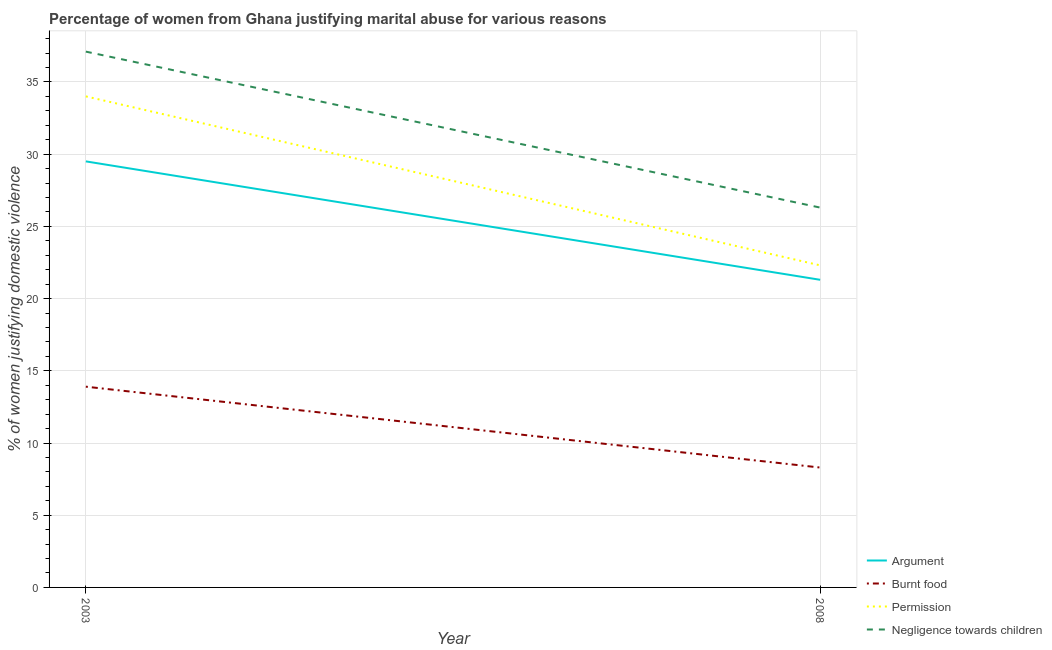What is the percentage of women justifying abuse in the case of an argument in 2003?
Give a very brief answer. 29.5. Across all years, what is the minimum percentage of women justifying abuse in the case of an argument?
Offer a terse response. 21.3. What is the total percentage of women justifying abuse for burning food in the graph?
Your answer should be very brief. 22.2. What is the difference between the percentage of women justifying abuse for burning food in 2003 and that in 2008?
Your answer should be very brief. 5.6. What is the difference between the percentage of women justifying abuse in the case of an argument in 2003 and the percentage of women justifying abuse for burning food in 2008?
Offer a very short reply. 21.2. What is the average percentage of women justifying abuse in the case of an argument per year?
Provide a short and direct response. 25.4. In the year 2003, what is the difference between the percentage of women justifying abuse for going without permission and percentage of women justifying abuse in the case of an argument?
Ensure brevity in your answer.  4.5. What is the ratio of the percentage of women justifying abuse for going without permission in 2003 to that in 2008?
Offer a terse response. 1.52. Is the percentage of women justifying abuse for showing negligence towards children strictly greater than the percentage of women justifying abuse for going without permission over the years?
Offer a very short reply. Yes. How many years are there in the graph?
Offer a terse response. 2. What is the difference between two consecutive major ticks on the Y-axis?
Make the answer very short. 5. Does the graph contain any zero values?
Make the answer very short. No. Does the graph contain grids?
Keep it short and to the point. Yes. Where does the legend appear in the graph?
Provide a short and direct response. Bottom right. How many legend labels are there?
Your response must be concise. 4. How are the legend labels stacked?
Your response must be concise. Vertical. What is the title of the graph?
Your answer should be compact. Percentage of women from Ghana justifying marital abuse for various reasons. Does "Compensation of employees" appear as one of the legend labels in the graph?
Ensure brevity in your answer.  No. What is the label or title of the X-axis?
Your response must be concise. Year. What is the label or title of the Y-axis?
Keep it short and to the point. % of women justifying domestic violence. What is the % of women justifying domestic violence in Argument in 2003?
Provide a short and direct response. 29.5. What is the % of women justifying domestic violence of Burnt food in 2003?
Keep it short and to the point. 13.9. What is the % of women justifying domestic violence in Permission in 2003?
Your answer should be very brief. 34. What is the % of women justifying domestic violence in Negligence towards children in 2003?
Ensure brevity in your answer.  37.1. What is the % of women justifying domestic violence of Argument in 2008?
Offer a terse response. 21.3. What is the % of women justifying domestic violence of Permission in 2008?
Ensure brevity in your answer.  22.3. What is the % of women justifying domestic violence of Negligence towards children in 2008?
Your response must be concise. 26.3. Across all years, what is the maximum % of women justifying domestic violence of Argument?
Ensure brevity in your answer.  29.5. Across all years, what is the maximum % of women justifying domestic violence in Burnt food?
Give a very brief answer. 13.9. Across all years, what is the maximum % of women justifying domestic violence in Negligence towards children?
Your answer should be very brief. 37.1. Across all years, what is the minimum % of women justifying domestic violence of Argument?
Your answer should be compact. 21.3. Across all years, what is the minimum % of women justifying domestic violence in Burnt food?
Your answer should be very brief. 8.3. Across all years, what is the minimum % of women justifying domestic violence of Permission?
Make the answer very short. 22.3. Across all years, what is the minimum % of women justifying domestic violence in Negligence towards children?
Make the answer very short. 26.3. What is the total % of women justifying domestic violence of Argument in the graph?
Provide a short and direct response. 50.8. What is the total % of women justifying domestic violence in Permission in the graph?
Provide a short and direct response. 56.3. What is the total % of women justifying domestic violence of Negligence towards children in the graph?
Give a very brief answer. 63.4. What is the difference between the % of women justifying domestic violence of Permission in 2003 and that in 2008?
Your response must be concise. 11.7. What is the difference between the % of women justifying domestic violence of Argument in 2003 and the % of women justifying domestic violence of Burnt food in 2008?
Provide a succinct answer. 21.2. What is the difference between the % of women justifying domestic violence in Argument in 2003 and the % of women justifying domestic violence in Negligence towards children in 2008?
Ensure brevity in your answer.  3.2. What is the difference between the % of women justifying domestic violence in Burnt food in 2003 and the % of women justifying domestic violence in Permission in 2008?
Your answer should be compact. -8.4. What is the difference between the % of women justifying domestic violence of Permission in 2003 and the % of women justifying domestic violence of Negligence towards children in 2008?
Ensure brevity in your answer.  7.7. What is the average % of women justifying domestic violence in Argument per year?
Your answer should be very brief. 25.4. What is the average % of women justifying domestic violence in Burnt food per year?
Provide a short and direct response. 11.1. What is the average % of women justifying domestic violence of Permission per year?
Give a very brief answer. 28.15. What is the average % of women justifying domestic violence in Negligence towards children per year?
Provide a succinct answer. 31.7. In the year 2003, what is the difference between the % of women justifying domestic violence in Argument and % of women justifying domestic violence in Permission?
Keep it short and to the point. -4.5. In the year 2003, what is the difference between the % of women justifying domestic violence of Argument and % of women justifying domestic violence of Negligence towards children?
Offer a terse response. -7.6. In the year 2003, what is the difference between the % of women justifying domestic violence of Burnt food and % of women justifying domestic violence of Permission?
Keep it short and to the point. -20.1. In the year 2003, what is the difference between the % of women justifying domestic violence in Burnt food and % of women justifying domestic violence in Negligence towards children?
Your answer should be compact. -23.2. In the year 2003, what is the difference between the % of women justifying domestic violence in Permission and % of women justifying domestic violence in Negligence towards children?
Provide a succinct answer. -3.1. In the year 2008, what is the difference between the % of women justifying domestic violence in Burnt food and % of women justifying domestic violence in Negligence towards children?
Provide a short and direct response. -18. What is the ratio of the % of women justifying domestic violence of Argument in 2003 to that in 2008?
Provide a succinct answer. 1.39. What is the ratio of the % of women justifying domestic violence in Burnt food in 2003 to that in 2008?
Ensure brevity in your answer.  1.67. What is the ratio of the % of women justifying domestic violence in Permission in 2003 to that in 2008?
Your answer should be compact. 1.52. What is the ratio of the % of women justifying domestic violence of Negligence towards children in 2003 to that in 2008?
Your answer should be compact. 1.41. What is the difference between the highest and the second highest % of women justifying domestic violence of Argument?
Give a very brief answer. 8.2. What is the difference between the highest and the second highest % of women justifying domestic violence of Permission?
Give a very brief answer. 11.7. What is the difference between the highest and the second highest % of women justifying domestic violence in Negligence towards children?
Offer a very short reply. 10.8. What is the difference between the highest and the lowest % of women justifying domestic violence in Argument?
Keep it short and to the point. 8.2. 